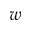<formula> <loc_0><loc_0><loc_500><loc_500>w</formula> 